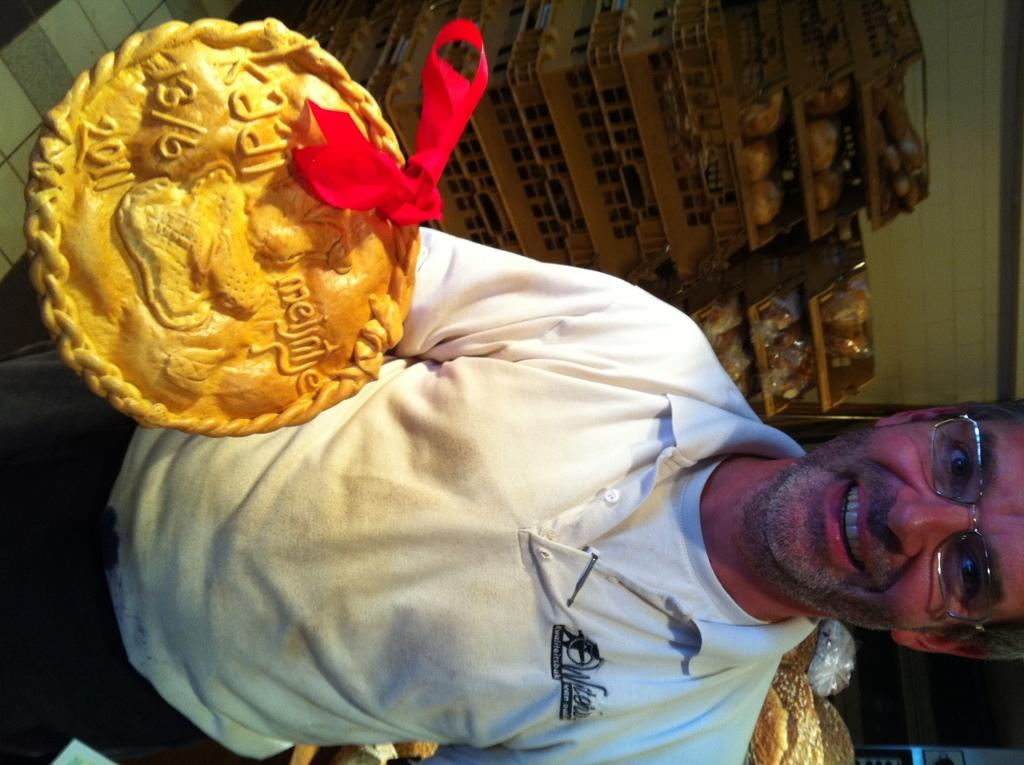What is the man in the image doing? The man is holding an object and smiling. What can be seen on the man's face? The man is wearing spectacles. What is visible in the background of the image? There are baskets, a wall, and other objects visible in the background. What type of note is the man holding in the image? The man is not holding a note in the image; he is holding an unspecified object. What color is the linen draped over the wall in the image? There is no linen draped over the wall in the image. Can you see any icicles hanging from the wall in the image? There are no icicles visible in the image. 